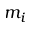<formula> <loc_0><loc_0><loc_500><loc_500>m _ { i }</formula> 